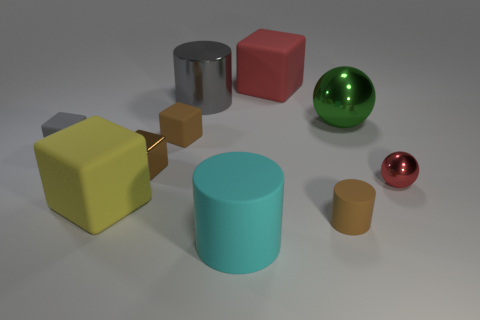Subtract all rubber cylinders. How many cylinders are left? 1 Subtract all yellow cubes. How many cubes are left? 4 Subtract 2 balls. How many balls are left? 0 Subtract 0 purple cylinders. How many objects are left? 10 Subtract all balls. How many objects are left? 8 Subtract all yellow spheres. Subtract all yellow cylinders. How many spheres are left? 2 Subtract all brown cylinders. How many red spheres are left? 1 Subtract all gray blocks. Subtract all large gray metal objects. How many objects are left? 8 Add 5 large cyan matte cylinders. How many large cyan matte cylinders are left? 6 Add 4 small metal balls. How many small metal balls exist? 5 